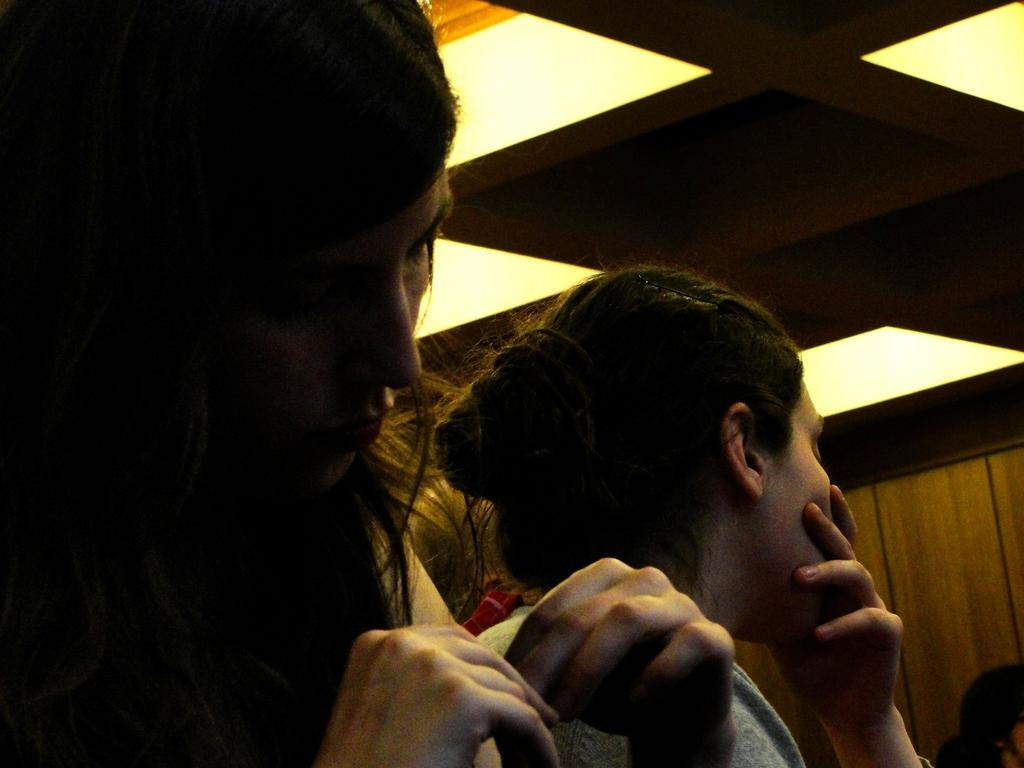What can be seen in the image? There are people standing in the image. What is present on the ceiling in the image? There are lights on the ceiling in the image. Can you see any fairies flying around the people in the image? No, there are no fairies present in the image. 